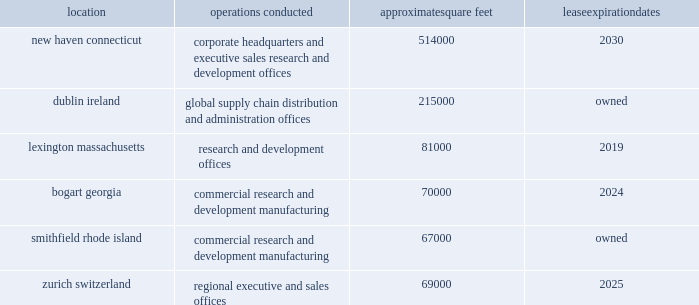Item 2 .
Properties .
We conduct our primary operations at the owned and leased facilities described below .
Location operations conducted approximate square feet expiration new haven , connecticut corporate headquarters and executive , sales , research and development offices 514000 .
We believe that our administrative office space is adequate to meet our needs for the foreseeable future .
We also believe that our research and development facilities and our manufacturing facility , together with third party manufacturing facilities , will be adequate for our on-going activities .
In addition to the locations above , we also lease space in other u.s .
Locations and in foreign countries to support our operations as a global organization .
As of december 31 , 2015 , we also leased approximately 254000 square feet in cheshire , connecticut , which was the previous location of our corporate headquarters and executive , sales , research and development offices .
In december 2015 , we entered into an early termination of this lease and will occupy this space through may 2016 .
In april 2014 , we purchased a fill/finish facility in athlone , ireland .
Following refurbishment of the facility , and after successful completion of the appropriate validation processes and regulatory approvals , the facility will become our first company-owned fill/finish and packaging facility for our commercial and clinical products .
In may 2015 , we announced plans to construct a new biologics manufacturing facility on our existing property in dublin ireland , which is expected to be completed by 2020 .
Item 3 .
Legal proceedings .
In may 2015 , we received a subpoena in connection with an investigation by the enforcement division of the sec requesting information related to our grant-making activities and compliance with the fcpa in various countries .
The sec also seeks information related to alexion 2019s recalls of specific lots of soliris and related securities disclosures .
In addition , in october 2015 , alexion received a request from the doj for the voluntary production of documents and other information pertaining to alexion's compliance with the fcpa .
Alexion is cooperating with these investigations .
At this time , alexion is unable to predict the duration , scope or outcome of these investigations .
Given the ongoing nature of these investigations , management does not currently believe a loss related to these matters is probable or that the potential magnitude of such loss or range of loss , if any , can be reasonably estimated .
Item 4 .
Mine safety disclosures .
Not applicable. .
How many square feet are leased by alexion pharmaceuticals , inc? 
Computations: (((514000 + 81000) + 70000) + 69000)
Answer: 734000.0. 